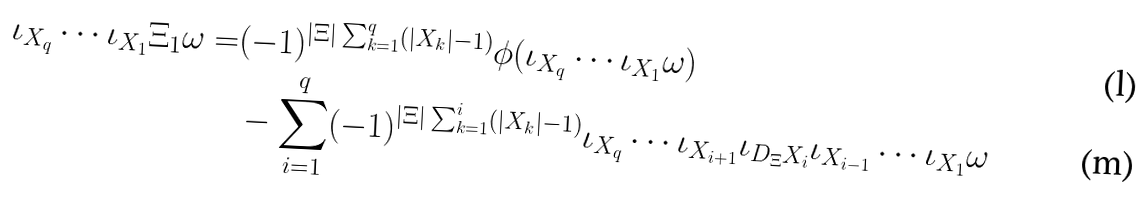Convert formula to latex. <formula><loc_0><loc_0><loc_500><loc_500>\iota _ { X _ { q } } \cdots \iota _ { X _ { 1 } } \Xi _ { 1 } \omega = & ( - 1 ) ^ { | \Xi | \sum _ { k = 1 } ^ { q } ( | X _ { k } | - 1 ) } \phi ( \iota _ { X _ { q } } \cdots \iota _ { X _ { 1 } } \omega ) \\ & - \sum _ { i = 1 } ^ { q } ( - 1 ) ^ { | \Xi | \sum _ { k = 1 } ^ { i } ( | X _ { k } | - 1 ) } \iota _ { X _ { q } } \cdots \iota _ { X _ { i + 1 } } \iota _ { D _ { \Xi } X _ { i } } \iota _ { X _ { i - 1 } } \cdots \iota _ { X _ { 1 } } \omega</formula> 